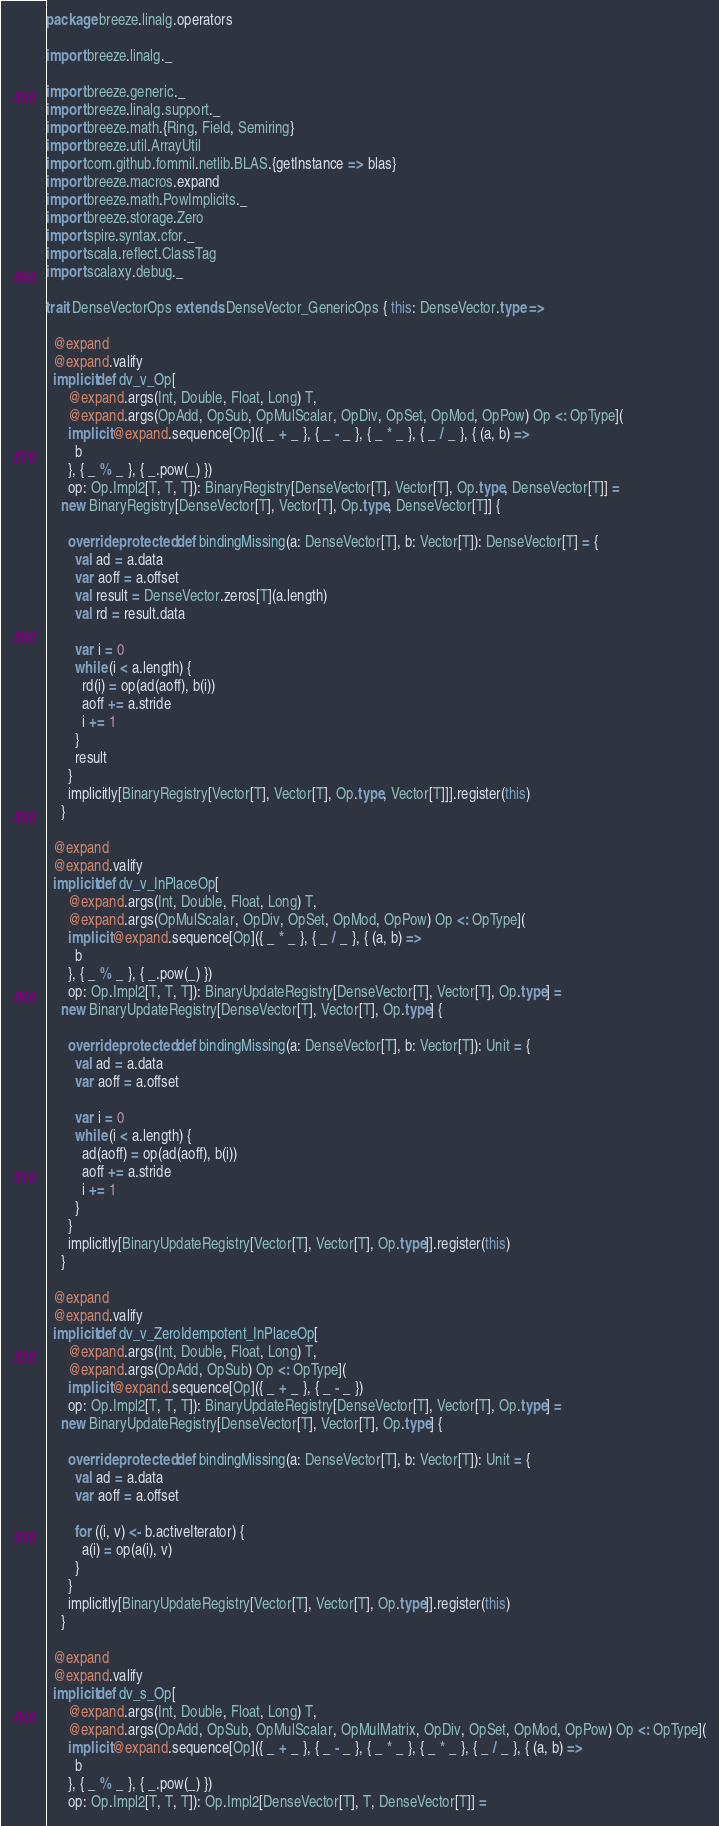Convert code to text. <code><loc_0><loc_0><loc_500><loc_500><_Scala_>package breeze.linalg.operators

import breeze.linalg._

import breeze.generic._
import breeze.linalg.support._
import breeze.math.{Ring, Field, Semiring}
import breeze.util.ArrayUtil
import com.github.fommil.netlib.BLAS.{getInstance => blas}
import breeze.macros.expand
import breeze.math.PowImplicits._
import breeze.storage.Zero
import spire.syntax.cfor._
import scala.reflect.ClassTag
import scalaxy.debug._

trait DenseVectorOps extends DenseVector_GenericOps { this: DenseVector.type =>

  @expand
  @expand.valify
  implicit def dv_v_Op[
      @expand.args(Int, Double, Float, Long) T,
      @expand.args(OpAdd, OpSub, OpMulScalar, OpDiv, OpSet, OpMod, OpPow) Op <: OpType](
      implicit @expand.sequence[Op]({ _ + _ }, { _ - _ }, { _ * _ }, { _ / _ }, { (a, b) =>
        b
      }, { _ % _ }, { _.pow(_) })
      op: Op.Impl2[T, T, T]): BinaryRegistry[DenseVector[T], Vector[T], Op.type, DenseVector[T]] =
    new BinaryRegistry[DenseVector[T], Vector[T], Op.type, DenseVector[T]] {

      override protected def bindingMissing(a: DenseVector[T], b: Vector[T]): DenseVector[T] = {
        val ad = a.data
        var aoff = a.offset
        val result = DenseVector.zeros[T](a.length)
        val rd = result.data

        var i = 0
        while (i < a.length) {
          rd(i) = op(ad(aoff), b(i))
          aoff += a.stride
          i += 1
        }
        result
      }
      implicitly[BinaryRegistry[Vector[T], Vector[T], Op.type, Vector[T]]].register(this)
    }

  @expand
  @expand.valify
  implicit def dv_v_InPlaceOp[
      @expand.args(Int, Double, Float, Long) T,
      @expand.args(OpMulScalar, OpDiv, OpSet, OpMod, OpPow) Op <: OpType](
      implicit @expand.sequence[Op]({ _ * _ }, { _ / _ }, { (a, b) =>
        b
      }, { _ % _ }, { _.pow(_) })
      op: Op.Impl2[T, T, T]): BinaryUpdateRegistry[DenseVector[T], Vector[T], Op.type] =
    new BinaryUpdateRegistry[DenseVector[T], Vector[T], Op.type] {

      override protected def bindingMissing(a: DenseVector[T], b: Vector[T]): Unit = {
        val ad = a.data
        var aoff = a.offset

        var i = 0
        while (i < a.length) {
          ad(aoff) = op(ad(aoff), b(i))
          aoff += a.stride
          i += 1
        }
      }
      implicitly[BinaryUpdateRegistry[Vector[T], Vector[T], Op.type]].register(this)
    }

  @expand
  @expand.valify
  implicit def dv_v_ZeroIdempotent_InPlaceOp[
      @expand.args(Int, Double, Float, Long) T,
      @expand.args(OpAdd, OpSub) Op <: OpType](
      implicit @expand.sequence[Op]({ _ + _ }, { _ - _ })
      op: Op.Impl2[T, T, T]): BinaryUpdateRegistry[DenseVector[T], Vector[T], Op.type] =
    new BinaryUpdateRegistry[DenseVector[T], Vector[T], Op.type] {

      override protected def bindingMissing(a: DenseVector[T], b: Vector[T]): Unit = {
        val ad = a.data
        var aoff = a.offset

        for ((i, v) <- b.activeIterator) {
          a(i) = op(a(i), v)
        }
      }
      implicitly[BinaryUpdateRegistry[Vector[T], Vector[T], Op.type]].register(this)
    }

  @expand
  @expand.valify
  implicit def dv_s_Op[
      @expand.args(Int, Double, Float, Long) T,
      @expand.args(OpAdd, OpSub, OpMulScalar, OpMulMatrix, OpDiv, OpSet, OpMod, OpPow) Op <: OpType](
      implicit @expand.sequence[Op]({ _ + _ }, { _ - _ }, { _ * _ }, { _ * _ }, { _ / _ }, { (a, b) =>
        b
      }, { _ % _ }, { _.pow(_) })
      op: Op.Impl2[T, T, T]): Op.Impl2[DenseVector[T], T, DenseVector[T]] =</code> 